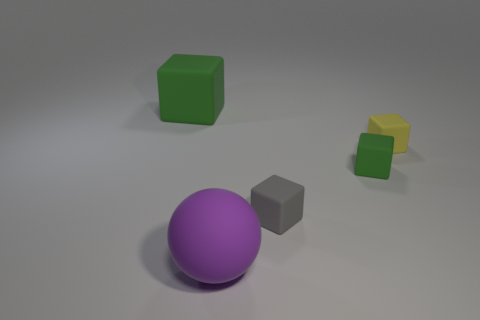The tiny matte object that is the same color as the large block is what shape?
Keep it short and to the point. Cube. What number of purple things are either large matte spheres or small rubber things?
Offer a very short reply. 1. Is the number of large purple spheres right of the ball less than the number of green objects that are on the right side of the large green cube?
Make the answer very short. Yes. There is a purple matte sphere; is it the same size as the green thing in front of the yellow matte thing?
Offer a very short reply. No. What number of other blocks are the same size as the yellow cube?
Ensure brevity in your answer.  2. How many large things are gray cubes or red things?
Your response must be concise. 0. Is there a big green cylinder?
Give a very brief answer. No. Is the number of green rubber objects on the right side of the big green thing greater than the number of small green rubber blocks that are in front of the tiny gray thing?
Make the answer very short. Yes. The thing that is on the left side of the matte object in front of the gray rubber block is what color?
Keep it short and to the point. Green. Are there any other matte blocks of the same color as the big rubber block?
Your response must be concise. Yes. 